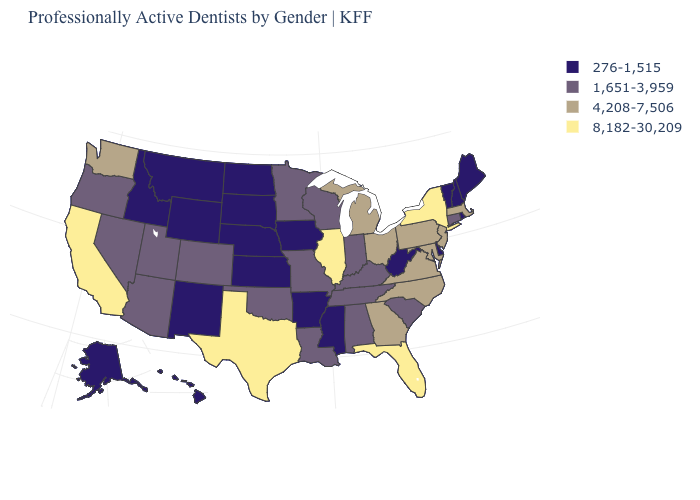What is the value of Ohio?
Write a very short answer. 4,208-7,506. Does the first symbol in the legend represent the smallest category?
Keep it brief. Yes. Which states have the lowest value in the USA?
Short answer required. Alaska, Arkansas, Delaware, Hawaii, Idaho, Iowa, Kansas, Maine, Mississippi, Montana, Nebraska, New Hampshire, New Mexico, North Dakota, Rhode Island, South Dakota, Vermont, West Virginia, Wyoming. What is the value of New Mexico?
Short answer required. 276-1,515. What is the value of Massachusetts?
Keep it brief. 4,208-7,506. What is the lowest value in the West?
Concise answer only. 276-1,515. Does Hawaii have a lower value than Missouri?
Answer briefly. Yes. Does the first symbol in the legend represent the smallest category?
Give a very brief answer. Yes. Name the states that have a value in the range 1,651-3,959?
Be succinct. Alabama, Arizona, Colorado, Connecticut, Indiana, Kentucky, Louisiana, Minnesota, Missouri, Nevada, Oklahoma, Oregon, South Carolina, Tennessee, Utah, Wisconsin. What is the value of Pennsylvania?
Quick response, please. 4,208-7,506. Does Wisconsin have the lowest value in the MidWest?
Answer briefly. No. What is the value of South Carolina?
Answer briefly. 1,651-3,959. What is the value of West Virginia?
Short answer required. 276-1,515. Name the states that have a value in the range 1,651-3,959?
Write a very short answer. Alabama, Arizona, Colorado, Connecticut, Indiana, Kentucky, Louisiana, Minnesota, Missouri, Nevada, Oklahoma, Oregon, South Carolina, Tennessee, Utah, Wisconsin. What is the lowest value in states that border Oklahoma?
Concise answer only. 276-1,515. 